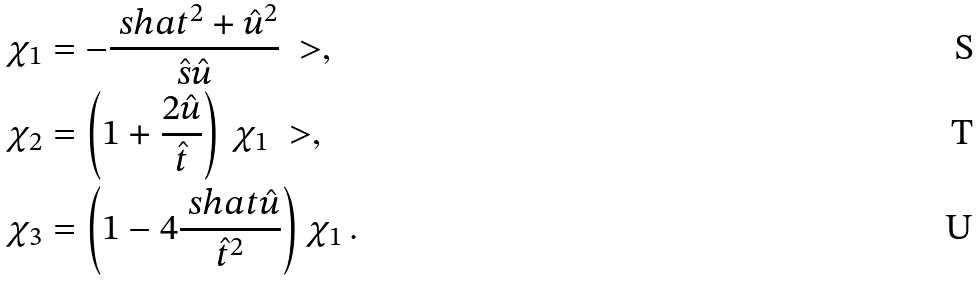<formula> <loc_0><loc_0><loc_500><loc_500>\chi _ { 1 } & = - \frac { \ s h a t ^ { 2 } + \hat { u } ^ { 2 } } { \hat { s } \hat { u } } \ > , \\ \chi _ { 2 } & = \left ( 1 + \frac { 2 \hat { u } } { \hat { t } } \right ) \, \chi _ { 1 } \ > , \\ \chi _ { 3 } & = \left ( 1 - 4 \frac { \ s h a t \hat { u } } { \hat { t } ^ { 2 } } \right ) \chi _ { 1 } \, .</formula> 